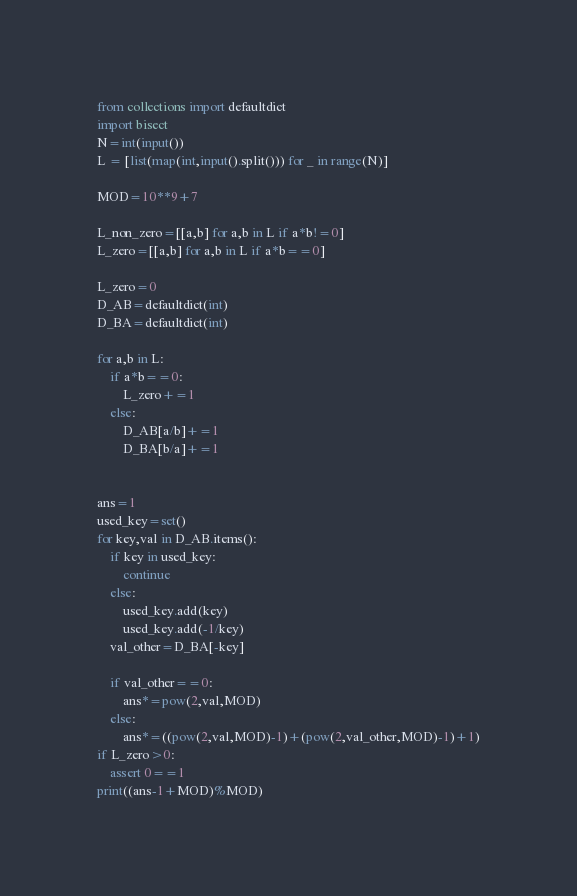<code> <loc_0><loc_0><loc_500><loc_500><_Python_>from collections import defaultdict
import bisect
N=int(input())
L = [list(map(int,input().split())) for _ in range(N)]

MOD=10**9+7

L_non_zero=[[a,b] for a,b in L if a*b!=0]
L_zero=[[a,b] for a,b in L if a*b==0]

L_zero=0
D_AB=defaultdict(int)
D_BA=defaultdict(int)

for a,b in L:
    if a*b==0:
        L_zero+=1
    else:
        D_AB[a/b]+=1
        D_BA[b/a]+=1


ans=1
used_key=set()
for key,val in D_AB.items():
    if key in used_key:
        continue
    else:
        used_key.add(key)
        used_key.add(-1/key)
    val_other=D_BA[-key]

    if val_other==0:
        ans*=pow(2,val,MOD)
    else:
        ans*=((pow(2,val,MOD)-1)+(pow(2,val_other,MOD)-1)+1)
if L_zero>0:
    assert 0==1
print((ans-1+MOD)%MOD)
</code> 